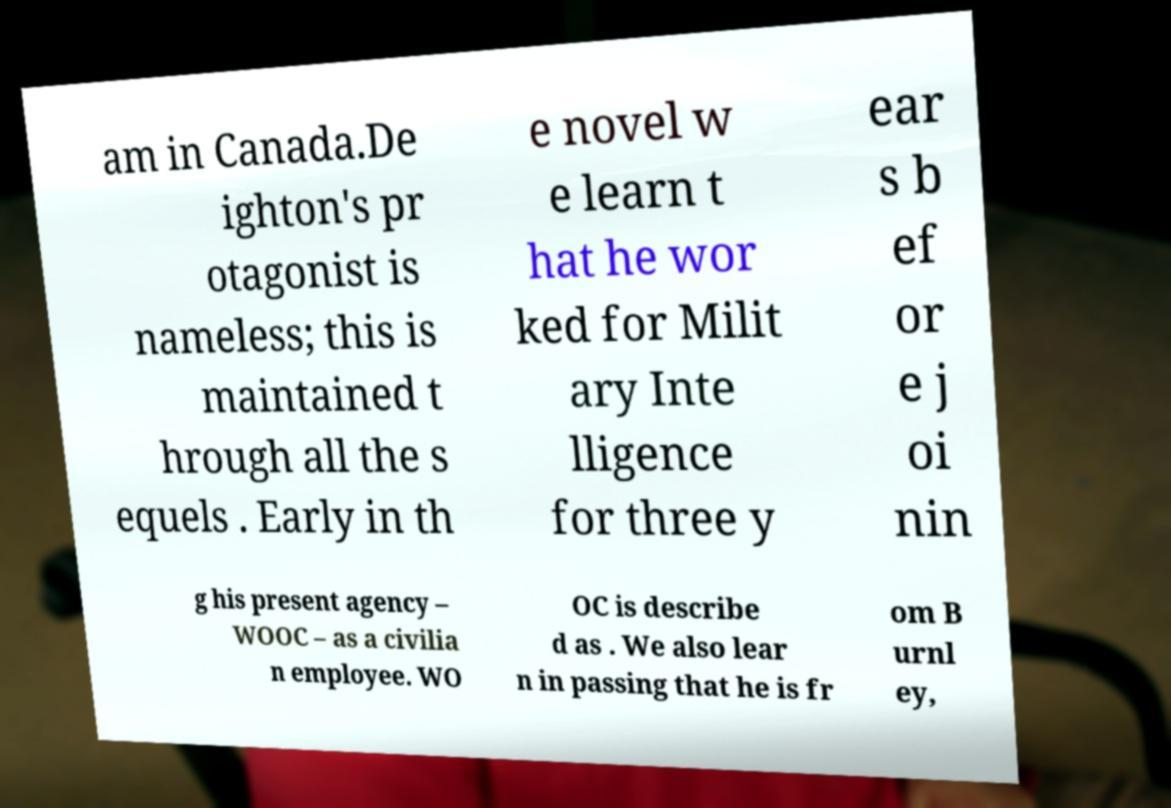There's text embedded in this image that I need extracted. Can you transcribe it verbatim? am in Canada.De ighton's pr otagonist is nameless; this is maintained t hrough all the s equels . Early in th e novel w e learn t hat he wor ked for Milit ary Inte lligence for three y ear s b ef or e j oi nin g his present agency – WOOC – as a civilia n employee. WO OC is describe d as . We also lear n in passing that he is fr om B urnl ey, 